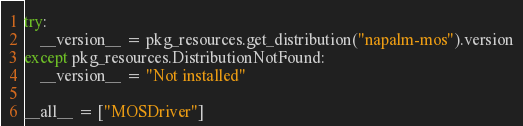<code> <loc_0><loc_0><loc_500><loc_500><_Python_>
try:
    __version__ = pkg_resources.get_distribution("napalm-mos").version
except pkg_resources.DistributionNotFound:
    __version__ = "Not installed"

__all__ = ["MOSDriver"]
</code> 